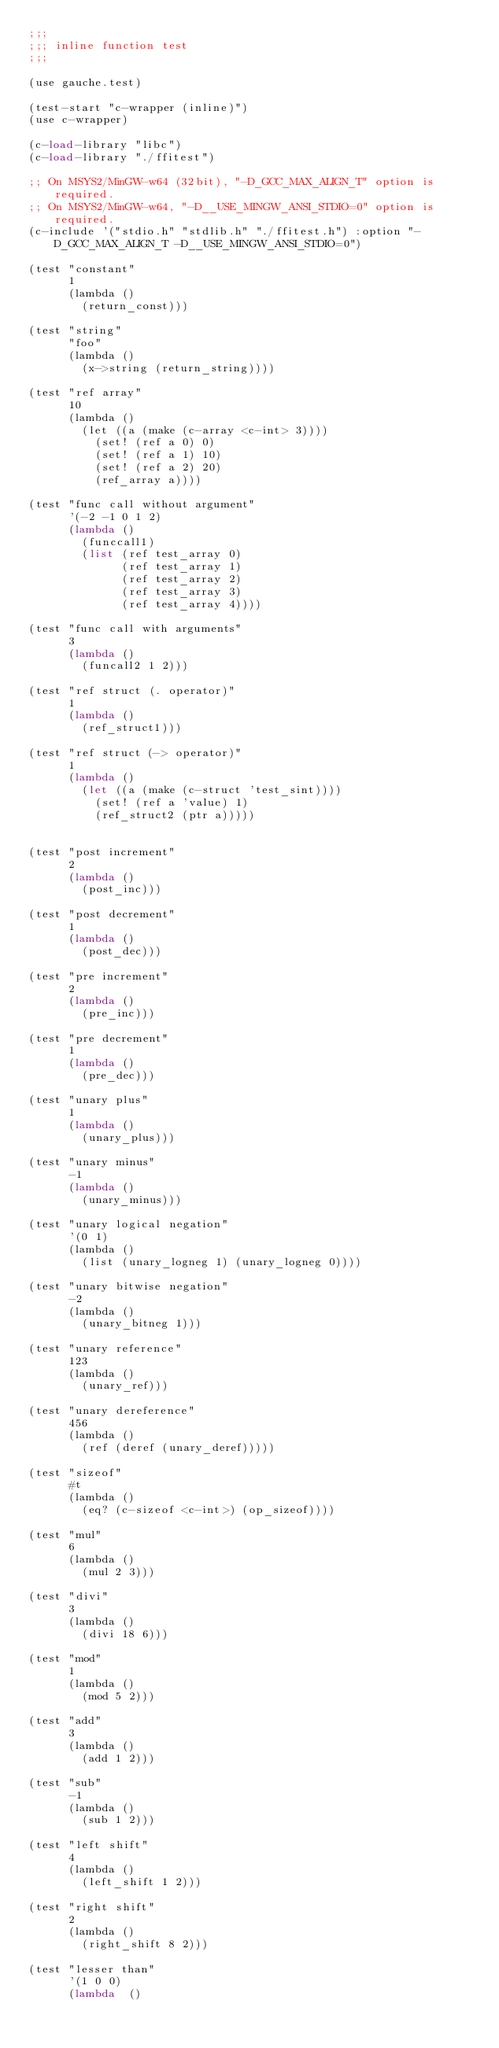Convert code to text. <code><loc_0><loc_0><loc_500><loc_500><_Scheme_>;;;
;;; inline function test
;;;

(use gauche.test)

(test-start "c-wrapper (inline)")
(use c-wrapper)

(c-load-library "libc")
(c-load-library "./ffitest")

;; On MSYS2/MinGW-w64 (32bit), "-D_GCC_MAX_ALIGN_T" option is required.
;; On MSYS2/MinGW-w64, "-D__USE_MINGW_ANSI_STDIO=0" option is required.
(c-include '("stdio.h" "stdlib.h" "./ffitest.h") :option "-D_GCC_MAX_ALIGN_T -D__USE_MINGW_ANSI_STDIO=0")

(test "constant"
      1
      (lambda ()
        (return_const)))

(test "string"
      "foo"
      (lambda ()
        (x->string (return_string))))

(test "ref array"
      10
      (lambda ()
        (let ((a (make (c-array <c-int> 3))))
          (set! (ref a 0) 0)
          (set! (ref a 1) 10)
          (set! (ref a 2) 20)
          (ref_array a))))

(test "func call without argument"
      '(-2 -1 0 1 2)
      (lambda ()
        (funccall1)
        (list (ref test_array 0)
              (ref test_array 1)
              (ref test_array 2)
              (ref test_array 3)
              (ref test_array 4))))

(test "func call with arguments"
      3
      (lambda ()
        (funcall2 1 2)))

(test "ref struct (. operator)"
      1
      (lambda ()
        (ref_struct1)))

(test "ref struct (-> operator)"
      1
      (lambda ()
        (let ((a (make (c-struct 'test_sint))))
          (set! (ref a 'value) 1)
          (ref_struct2 (ptr a)))))


(test "post increment"
      2
      (lambda ()
        (post_inc)))

(test "post decrement"
      1
      (lambda ()
        (post_dec)))

(test "pre increment"
      2
      (lambda ()
        (pre_inc)))

(test "pre decrement"
      1
      (lambda ()
        (pre_dec)))

(test "unary plus"
      1
      (lambda ()
        (unary_plus)))

(test "unary minus"
      -1
      (lambda ()
        (unary_minus)))

(test "unary logical negation"
      '(0 1)
      (lambda ()
        (list (unary_logneg 1) (unary_logneg 0))))

(test "unary bitwise negation"
      -2
      (lambda ()
        (unary_bitneg 1)))

(test "unary reference"
      123
      (lambda ()
        (unary_ref)))

(test "unary dereference"
      456
      (lambda ()
        (ref (deref (unary_deref)))))

(test "sizeof"
      #t
      (lambda ()
        (eq? (c-sizeof <c-int>) (op_sizeof))))

(test "mul"
      6
      (lambda ()
        (mul 2 3)))

(test "divi"
      3
      (lambda ()
        (divi 18 6)))

(test "mod"
      1
      (lambda ()
        (mod 5 2)))

(test "add"
      3
      (lambda ()
        (add 1 2)))

(test "sub"
      -1
      (lambda ()
        (sub 1 2)))

(test "left shift"
      4
      (lambda ()
        (left_shift 1 2)))

(test "right shift"
      2
      (lambda ()
        (right_shift 8 2)))

(test "lesser than"
      '(1 0 0)
      (lambda  ()</code> 